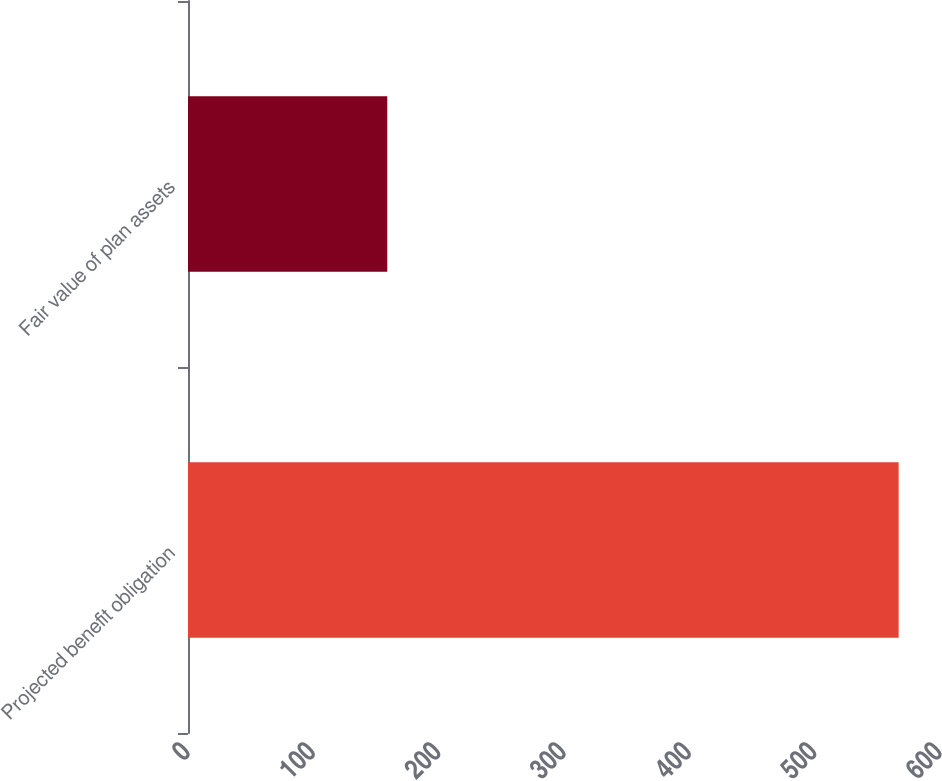<chart> <loc_0><loc_0><loc_500><loc_500><bar_chart><fcel>Projected benefit obligation<fcel>Fair value of plan assets<nl><fcel>567<fcel>159<nl></chart> 